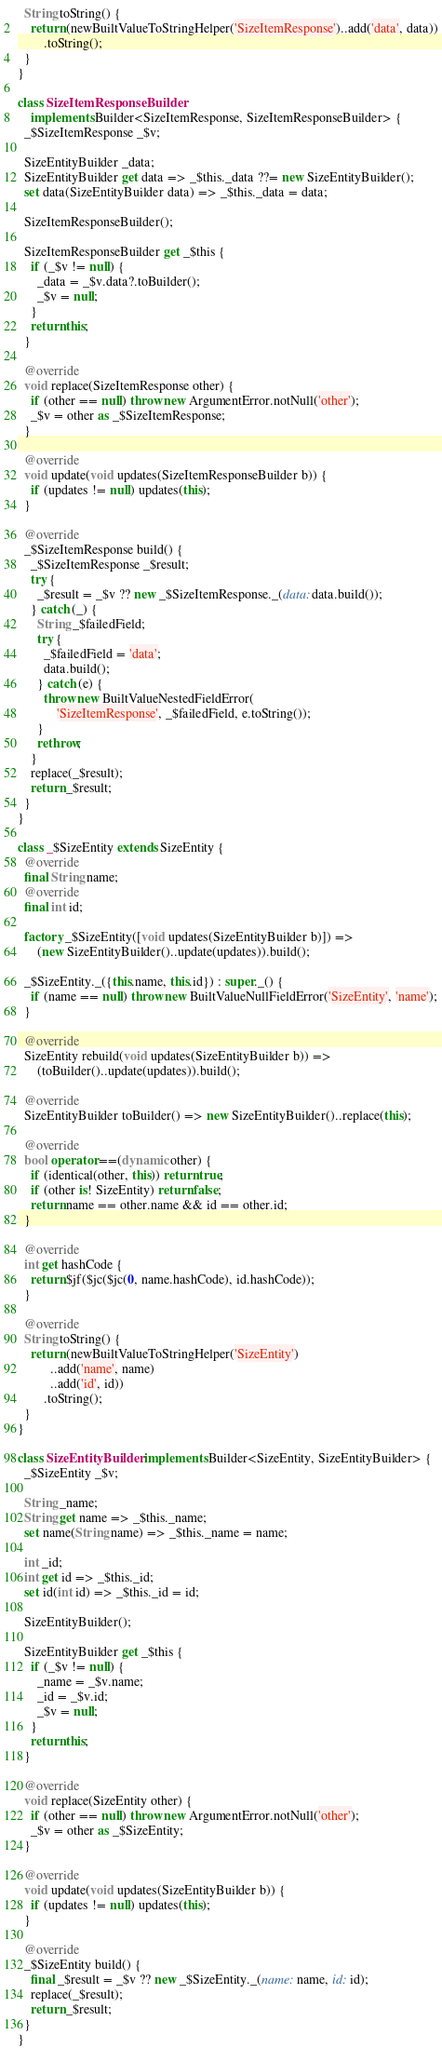<code> <loc_0><loc_0><loc_500><loc_500><_Dart_>  String toString() {
    return (newBuiltValueToStringHelper('SizeItemResponse')..add('data', data))
        .toString();
  }
}

class SizeItemResponseBuilder
    implements Builder<SizeItemResponse, SizeItemResponseBuilder> {
  _$SizeItemResponse _$v;

  SizeEntityBuilder _data;
  SizeEntityBuilder get data => _$this._data ??= new SizeEntityBuilder();
  set data(SizeEntityBuilder data) => _$this._data = data;

  SizeItemResponseBuilder();

  SizeItemResponseBuilder get _$this {
    if (_$v != null) {
      _data = _$v.data?.toBuilder();
      _$v = null;
    }
    return this;
  }

  @override
  void replace(SizeItemResponse other) {
    if (other == null) throw new ArgumentError.notNull('other');
    _$v = other as _$SizeItemResponse;
  }

  @override
  void update(void updates(SizeItemResponseBuilder b)) {
    if (updates != null) updates(this);
  }

  @override
  _$SizeItemResponse build() {
    _$SizeItemResponse _$result;
    try {
      _$result = _$v ?? new _$SizeItemResponse._(data: data.build());
    } catch (_) {
      String _$failedField;
      try {
        _$failedField = 'data';
        data.build();
      } catch (e) {
        throw new BuiltValueNestedFieldError(
            'SizeItemResponse', _$failedField, e.toString());
      }
      rethrow;
    }
    replace(_$result);
    return _$result;
  }
}

class _$SizeEntity extends SizeEntity {
  @override
  final String name;
  @override
  final int id;

  factory _$SizeEntity([void updates(SizeEntityBuilder b)]) =>
      (new SizeEntityBuilder()..update(updates)).build();

  _$SizeEntity._({this.name, this.id}) : super._() {
    if (name == null) throw new BuiltValueNullFieldError('SizeEntity', 'name');
  }

  @override
  SizeEntity rebuild(void updates(SizeEntityBuilder b)) =>
      (toBuilder()..update(updates)).build();

  @override
  SizeEntityBuilder toBuilder() => new SizeEntityBuilder()..replace(this);

  @override
  bool operator ==(dynamic other) {
    if (identical(other, this)) return true;
    if (other is! SizeEntity) return false;
    return name == other.name && id == other.id;
  }

  @override
  int get hashCode {
    return $jf($jc($jc(0, name.hashCode), id.hashCode));
  }

  @override
  String toString() {
    return (newBuiltValueToStringHelper('SizeEntity')
          ..add('name', name)
          ..add('id', id))
        .toString();
  }
}

class SizeEntityBuilder implements Builder<SizeEntity, SizeEntityBuilder> {
  _$SizeEntity _$v;

  String _name;
  String get name => _$this._name;
  set name(String name) => _$this._name = name;

  int _id;
  int get id => _$this._id;
  set id(int id) => _$this._id = id;

  SizeEntityBuilder();

  SizeEntityBuilder get _$this {
    if (_$v != null) {
      _name = _$v.name;
      _id = _$v.id;
      _$v = null;
    }
    return this;
  }

  @override
  void replace(SizeEntity other) {
    if (other == null) throw new ArgumentError.notNull('other');
    _$v = other as _$SizeEntity;
  }

  @override
  void update(void updates(SizeEntityBuilder b)) {
    if (updates != null) updates(this);
  }

  @override
  _$SizeEntity build() {
    final _$result = _$v ?? new _$SizeEntity._(name: name, id: id);
    replace(_$result);
    return _$result;
  }
}
</code> 